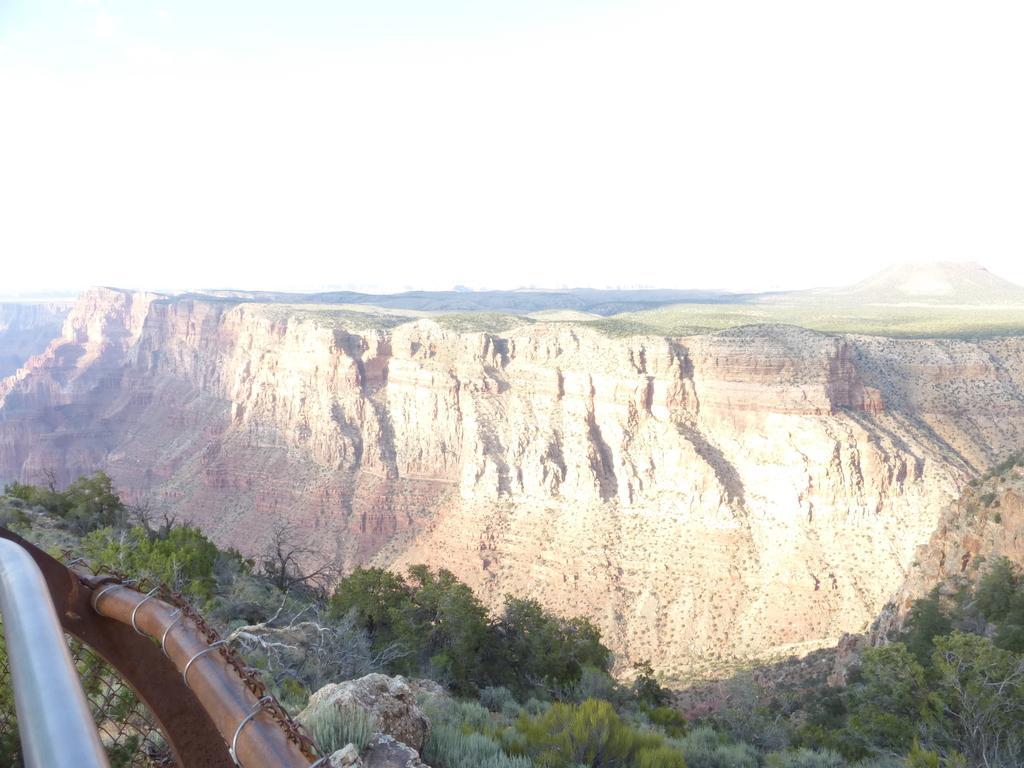How would you summarize this image in a sentence or two? In the bottom left hand corner we can see metal rods, in the background we can find few trees. 